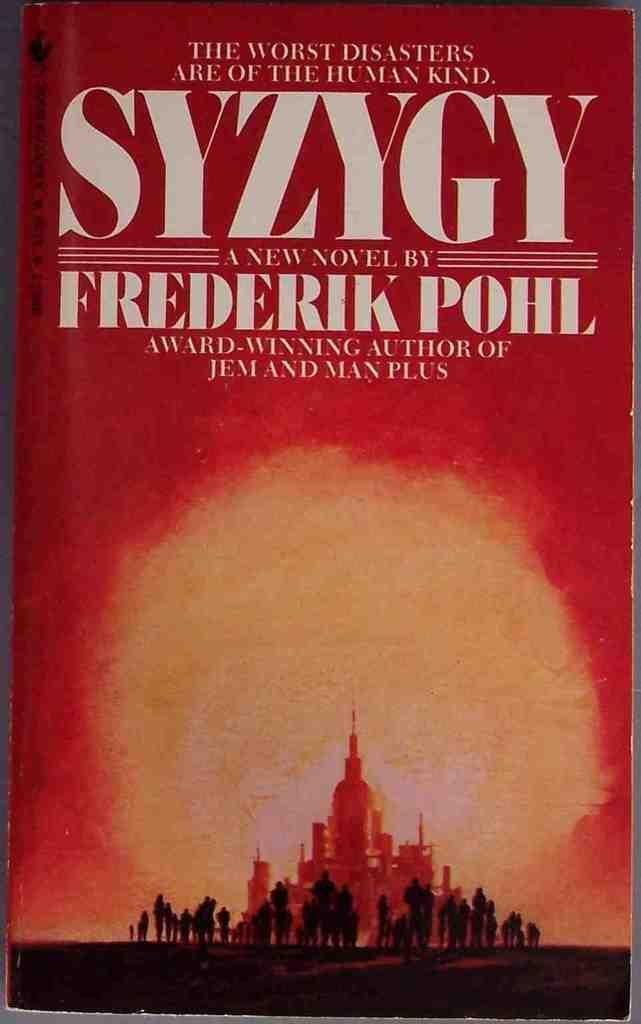<image>
Summarize the visual content of the image. Book that is called SYZYGY which is a novel by Frederik Pohl 